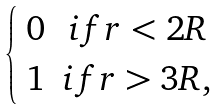<formula> <loc_0><loc_0><loc_500><loc_500>\begin{cases} \begin{array} { c c } 0 & i f r < 2 R \\ 1 & i f r > 3 R , \end{array} \end{cases}</formula> 